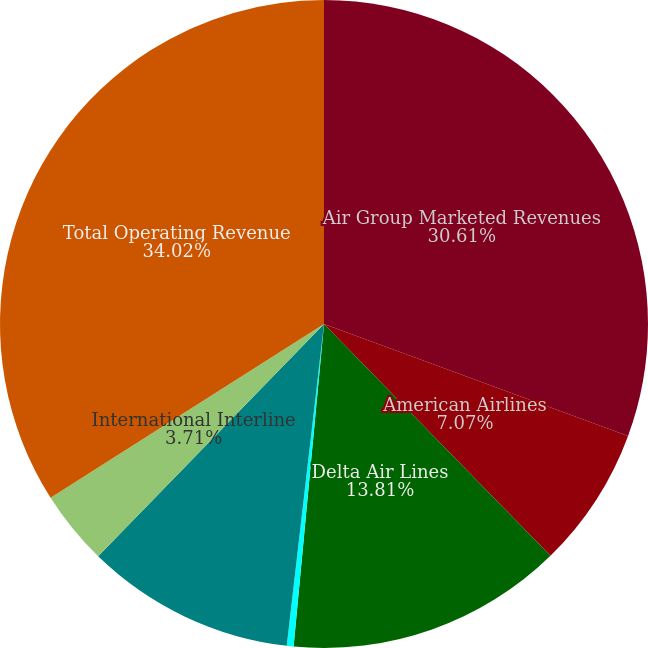<chart> <loc_0><loc_0><loc_500><loc_500><pie_chart><fcel>Air Group Marketed Revenues<fcel>American Airlines<fcel>Delta Air Lines<fcel>Others<fcel>Domestic Interline<fcel>International Interline<fcel>Total Operating Revenue<nl><fcel>30.61%<fcel>7.07%<fcel>13.81%<fcel>0.34%<fcel>10.44%<fcel>3.71%<fcel>34.01%<nl></chart> 